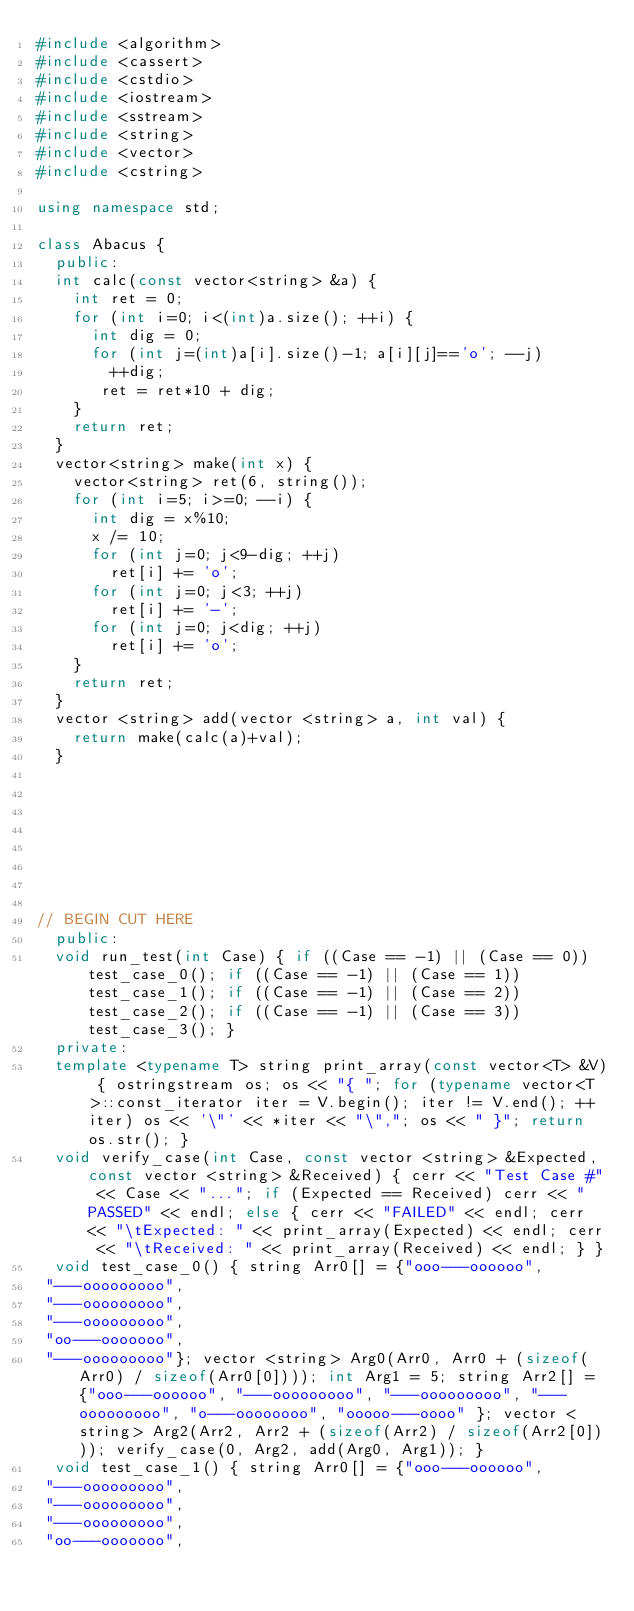<code> <loc_0><loc_0><loc_500><loc_500><_C++_>#include <algorithm>
#include <cassert>
#include <cstdio>
#include <iostream>
#include <sstream>
#include <string>
#include <vector>
#include <cstring>

using namespace std;

class Abacus {
	public:
	int calc(const vector<string> &a) {
	  int ret = 0;
	  for (int i=0; i<(int)a.size(); ++i) {
	    int dig = 0;
	    for (int j=(int)a[i].size()-1; a[i][j]=='o'; --j)
	      ++dig;
	     ret = ret*10 + dig;
	  }
	  return ret;
	}
	vector<string> make(int x) {
	  vector<string> ret(6, string());
	  for (int i=5; i>=0; --i) {
	    int dig = x%10;
	    x /= 10;
	    for (int j=0; j<9-dig; ++j)
	      ret[i] += 'o';
	    for (int j=0; j<3; ++j)
	      ret[i] += '-';
	    for (int j=0; j<dig; ++j)
	      ret[i] += 'o';
	  }
	  return ret;
	}
	vector <string> add(vector <string> a, int val) {
		return make(calc(a)+val);
	}







   
// BEGIN CUT HERE
	public:
	void run_test(int Case) { if ((Case == -1) || (Case == 0)) test_case_0(); if ((Case == -1) || (Case == 1)) test_case_1(); if ((Case == -1) || (Case == 2)) test_case_2(); if ((Case == -1) || (Case == 3)) test_case_3(); }
	private:
	template <typename T> string print_array(const vector<T> &V) { ostringstream os; os << "{ "; for (typename vector<T>::const_iterator iter = V.begin(); iter != V.end(); ++iter) os << '\"' << *iter << "\","; os << " }"; return os.str(); }
	void verify_case(int Case, const vector <string> &Expected, const vector <string> &Received) { cerr << "Test Case #" << Case << "..."; if (Expected == Received) cerr << "PASSED" << endl; else { cerr << "FAILED" << endl; cerr << "\tExpected: " << print_array(Expected) << endl; cerr << "\tReceived: " << print_array(Received) << endl; } }
	void test_case_0() { string Arr0[] = {"ooo---oooooo",
 "---ooooooooo",
 "---ooooooooo",
 "---ooooooooo",
 "oo---ooooooo",
 "---ooooooooo"}; vector <string> Arg0(Arr0, Arr0 + (sizeof(Arr0) / sizeof(Arr0[0]))); int Arg1 = 5; string Arr2[] = {"ooo---oooooo", "---ooooooooo", "---ooooooooo", "---ooooooooo", "o---oooooooo", "ooooo---oooo" }; vector <string> Arg2(Arr2, Arr2 + (sizeof(Arr2) / sizeof(Arr2[0]))); verify_case(0, Arg2, add(Arg0, Arg1)); }
	void test_case_1() { string Arr0[] = {"ooo---oooooo",
 "---ooooooooo",
 "---ooooooooo",
 "---ooooooooo",
 "oo---ooooooo",</code> 